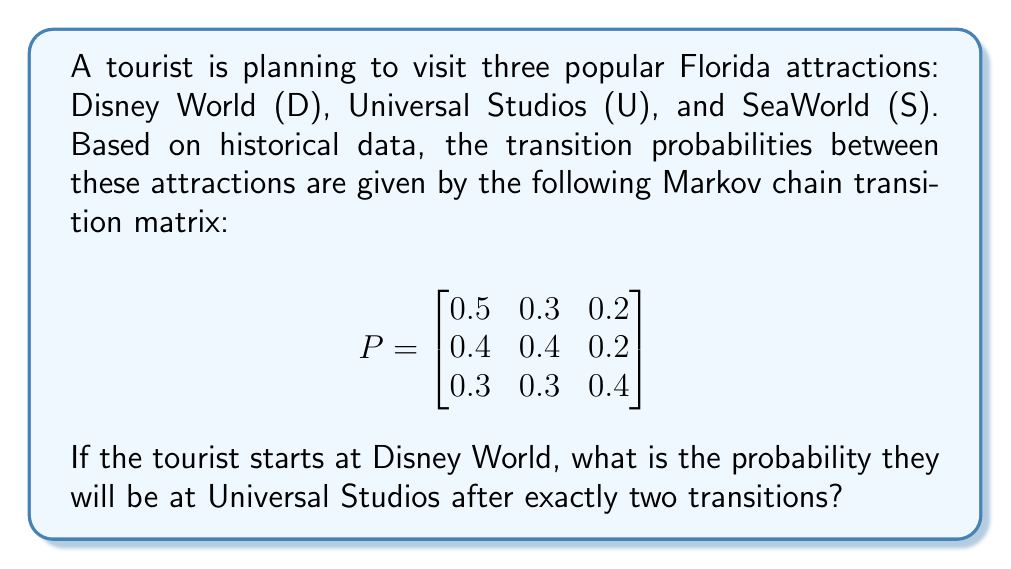Teach me how to tackle this problem. To solve this problem, we need to use the Chapman-Kolmogorov equations and calculate the two-step transition probability.

Step 1: Identify the initial state and target state.
- Initial state: Disney World (D)
- Target state after two transitions: Universal Studios (U)

Step 2: Calculate the two-step transition probability matrix by multiplying the given matrix by itself.

$$P^2 = P \times P = \begin{bmatrix}
0.5 & 0.3 & 0.2 \\
0.4 & 0.4 & 0.2 \\
0.3 & 0.3 & 0.4
\end{bmatrix} \times \begin{bmatrix}
0.5 & 0.3 & 0.2 \\
0.4 & 0.4 & 0.2 \\
0.3 & 0.3 & 0.4
\end{bmatrix}$$

Step 3: Perform matrix multiplication.

$$P^2 = \begin{bmatrix}
(0.5)(0.5) + (0.3)(0.4) + (0.2)(0.3) & (0.5)(0.3) + (0.3)(0.4) + (0.2)(0.3) & (0.5)(0.2) + (0.3)(0.2) + (0.2)(0.4) \\
(0.4)(0.5) + (0.4)(0.4) + (0.2)(0.3) & (0.4)(0.3) + (0.4)(0.4) + (0.2)(0.3) & (0.4)(0.2) + (0.4)(0.2) + (0.2)(0.4) \\
(0.3)(0.5) + (0.3)(0.4) + (0.4)(0.3) & (0.3)(0.3) + (0.3)(0.4) + (0.4)(0.3) & (0.3)(0.2) + (0.3)(0.2) + (0.4)(0.4)
\end{bmatrix}$$

Step 4: Calculate the resulting matrix.

$$P^2 = \begin{bmatrix}
0.43 & 0.33 & 0.24 \\
0.41 & 0.35 & 0.24 \\
0.37 & 0.33 & 0.30
\end{bmatrix}$$

Step 5: Identify the probability of being at Universal Studios (U) after two transitions, starting from Disney World (D).

This probability is given by the element in the first row (representing Disney World as the starting point) and second column (representing Universal Studios as the ending point) of the $P^2$ matrix.

The probability is 0.33 or 33%.
Answer: 0.33 